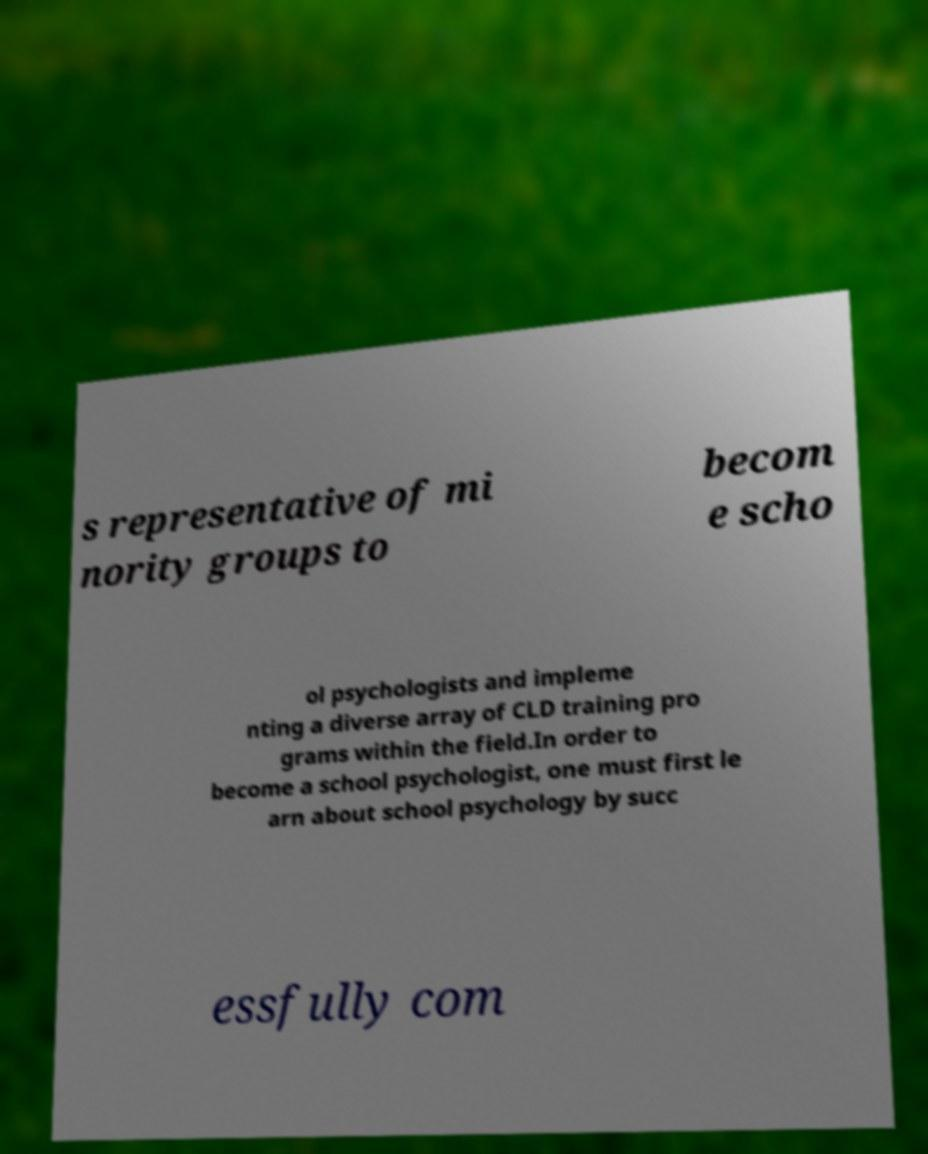I need the written content from this picture converted into text. Can you do that? s representative of mi nority groups to becom e scho ol psychologists and impleme nting a diverse array of CLD training pro grams within the field.In order to become a school psychologist, one must first le arn about school psychology by succ essfully com 